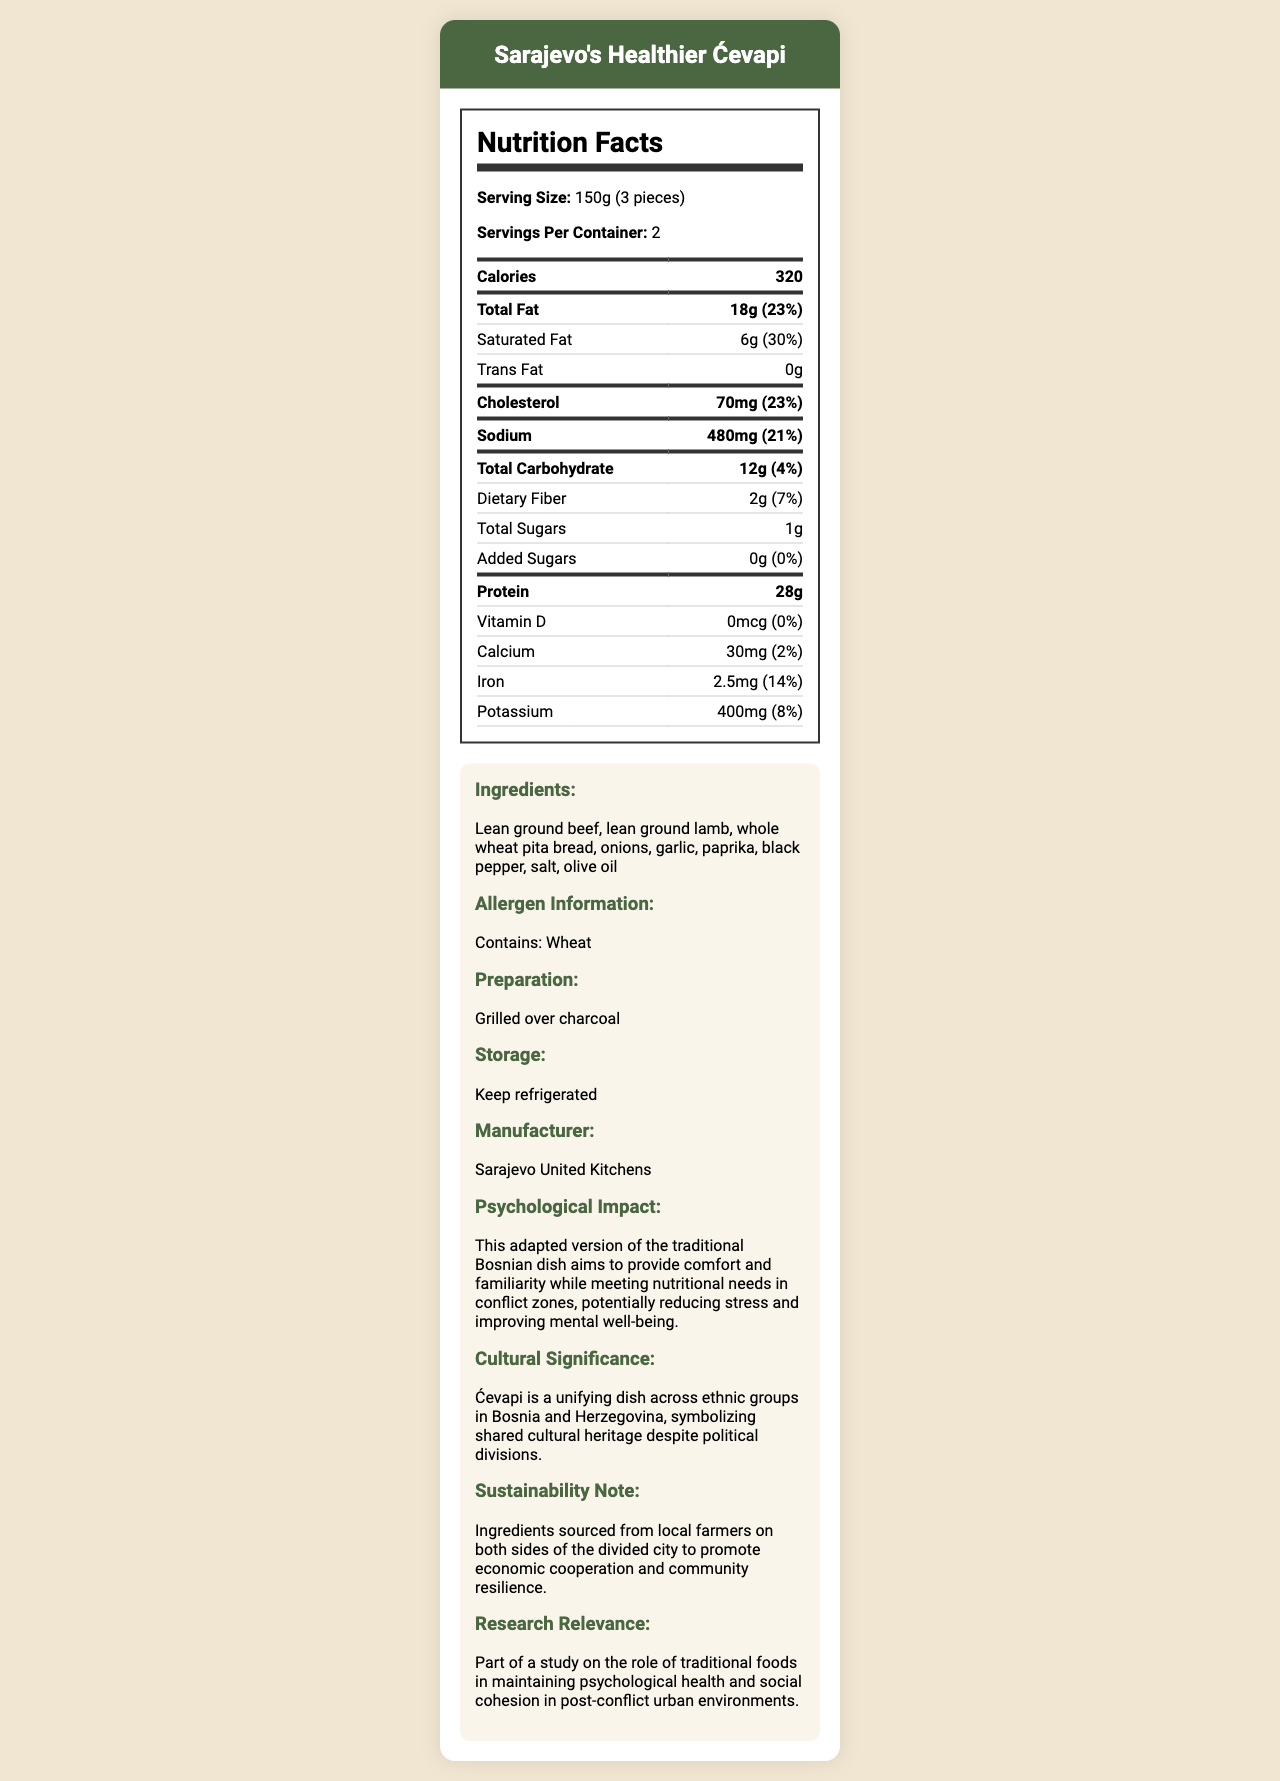what is the serving size for Sarajevo's Healthier Ćevapi? The serving size is explicitly stated under the section "Nutrition Facts."
Answer: 150g (3 pieces) how many servings are there per container? This information is listed right below the serving size in the "Nutrition Facts" section.
Answer: 2 how many calories are in one serving of Sarajevo's Healthier Ćevapi? The calorie count is prominently displayed in the "Nutrition Facts" section.
Answer: 320 what are the total fat and its daily value percentage per serving? These values are listed together in the "Nutrition Facts" table under "Total Fat."
Answer: 18g (23%) how much sodium is in each serving? The sodium content per serving is listed in the "Nutrition Facts" section.
Answer: 480mg how much protein does one serving contain? This value is clearly listed in the "Nutrition Facts" section.
Answer: 28g what is the main ingredient of Sarajevo's Healthier Ćevapi? A. Chicken B. Fish C. Lean ground beef D. Tofu The main ingredient is stated in the ingredients list as "Lean ground beef."
Answer: C what allergens are present in Sarajevo's Healthier Ćevapi? A. Dairy B. Wheat C. Eggs The allergen information specifically mentions "Contains: Wheat."
Answer: B the document mentions the psychological impact of Sarajevo's Healthier Ćevapi. What is it? The psychological impact is detailed in the "Psychological Impact" section near the end of the document.
Answer: This adapted version of the traditional Bosnian dish aims to provide comfort and familiarity while meeting nutritional needs in conflict zones, potentially reducing stress and improving mental well-being. what is the cultural significance of this dish? This cultural significance is described in the section labeled "Cultural Significance."
Answer: Ćevapi is a unifying dish across ethnic groups in Bosnia and Herzegovina, symbolizing shared cultural heritage despite political divisions. does the document provide information about the vitamin D content in the dish? The document specifically lists the vitamin D content as 0mcg (0%).
Answer: Yes explain the sustainability note mentioned in the document. This sustainability note shows an effort to promote economic cooperation and community resilience by sourcing ingredients locally from both sides of the divided city.
Answer: Ingredients sourced from local farmers on both sides of the divided city to promote economic cooperation and community resilience. what is the storage recommendation for this product? The storage recommendation is explicitly stated in the "Storage" section.
Answer: Keep refrigerated which company manufactures Sarajevo's Healthier Ćevapi? The manufacturer is listed in the "Manufacturer" section.
Answer: Sarajevo United Kitchens what type of cooking method is used in preparing this dish? The preparation method is mentioned as "Grilled over charcoal."
Answer: Grilled over charcoal is there any information about trans fat content in the dish? The document specifies that trans fat content is 0g in the "Nutrition Facts" section.
Answer: Yes, there is no trans fat (0g) summarize the primary focus of the document. The document is comprehensive in covering all aspects related to the nutritional value, ingredients, and broader social and psychological implications of Sarajevo's Healthier Ćevapi.
Answer: The document provides detailed nutritional information, ingredients, allergen information, psychological impact, cultural significance, sustainability note, and preparation and storage guidelines for Sarajevo's Healthier Ćevapi. It highlights the effort to adapt a traditional dish to meet nutritional guidelines while fostering psychological well-being and social cohesion in conflict zones. what is the daily value percentage of iron in each serving? The daily value percentage for iron is listed as 14% in the "Nutrition Facts" section.
Answer: 14% what is the total carbohydrate content in one serving, and what percentage of the daily value does it represent? The total carbohydrate content and its daily value percentage are listed in the "Nutrition Facts" section.
Answer: 12g (4%) what local economic benefits does the production of this dish promote? While the sustainability note mentions sourcing ingredients from local farmers to promote economic cooperation and community resilience, it does not specify the exact economic benefits.
Answer: Cannot be determined 